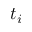Convert formula to latex. <formula><loc_0><loc_0><loc_500><loc_500>t _ { i }</formula> 